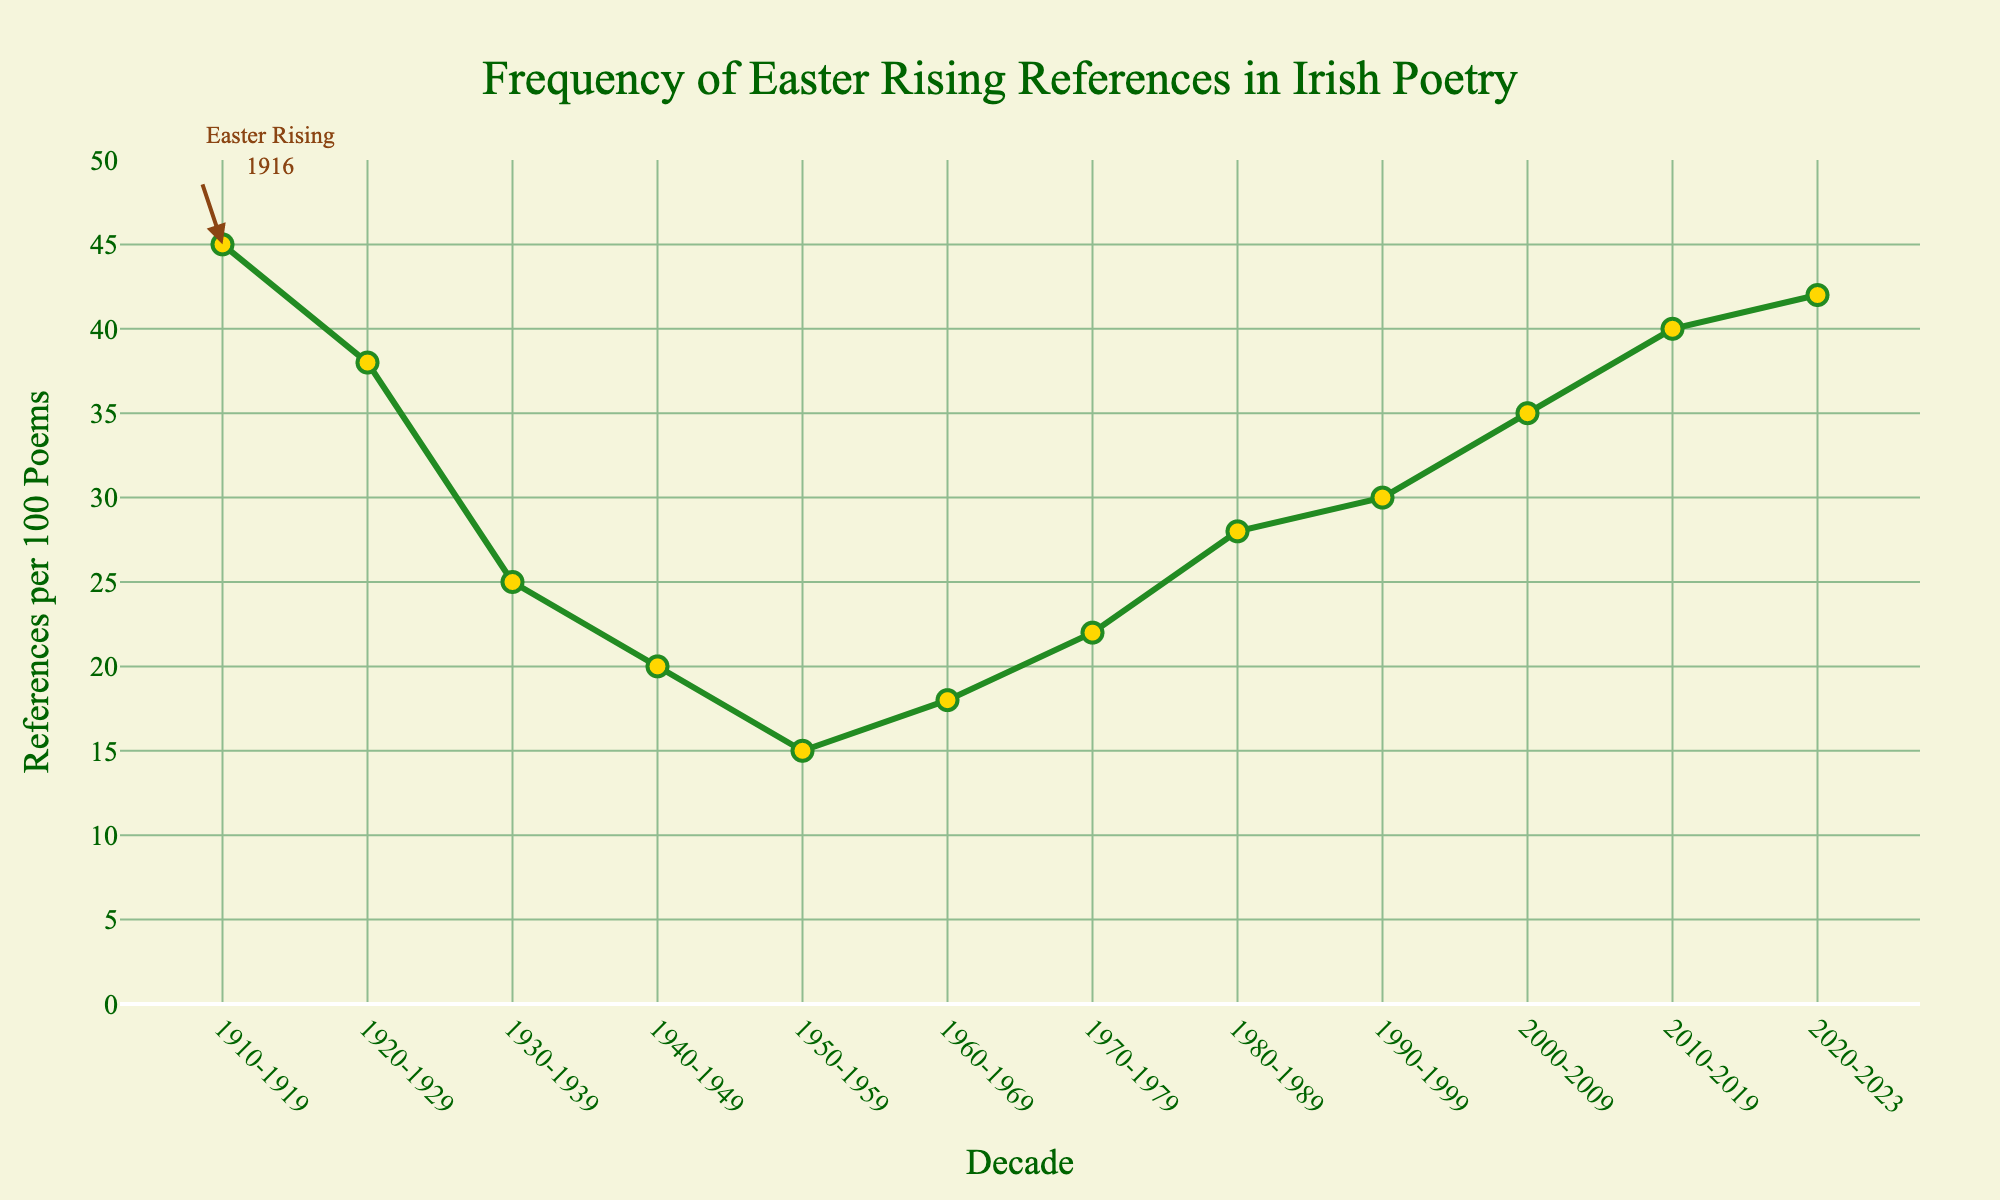Which decade shows the highest frequency of Easter Rising references? The decade with the highest point (marker) on the line plot represents the highest frequency. The marker at '1910-1919' is the highest, indicating 45 references per 100 poems.
Answer: '1910-1919' Between which two consecutive decades is the largest drop in Easter Rising references? To find the largest drop, compare the differences in references per 100 poems between each consecutive decade and identify the maximum. The difference from '1910-1919' (45) to '1920-1929' (38) is the largest drop of 7.
Answer: From '1910-1919' to '1920-1929' What is the overall trend in the frequency of references from 1910-1919 to 1950-1959? Look at the line connecting the markers from '1910-1919' to 1950-1959. The references drop continuously from 45, to 38, 25, 20, and finally 15. This shows a clear decreasing trend.
Answer: Decreasing Which decade experienced an increase in references compared to the one immediately prior to it? Compare the reference values of each decade with the one immediately before. The values increase from '1950-1959' (15) to '1960-1969' (18), '1960-1969' (18) to '1970-1979' (22), '1970-1979' (22) to '1980-1989' (28), '1980-1989' (28) to '1990-1999' (30), and '2000-2009' (35) to '2010-2019' (40), '2010-2019' (40) to '2020-2023' (42).
Answer: '1950-1959', '1960-1969', '1970-1979', '1980-1989', '1990-1999', '2000-2009', '2010-2019', '2020-2023' Based on visual inspection, how many decades show references between 30 and 40 per 100 poems? Count the markers on the y-axis that fall within the range of 30 to 40. Decades '1990-1999' (30), '2000-2009' (35), and '2010-2019' (40) fall in this range.
Answer: Three Compare the number of references in the decade 1940-1949 with 2020-2023. Which has more, and by how much? Check the y-axis for '1940-1949' (20) and '2020-2023' (42). '2020-2023' has 22 more references than '1940-1949'.
Answer: '2020-2023' has 22 more What is the average number of references per 100 poems across all decades? Sum all the reference values and divide by the number of decades (12). The sum is 358 and dividing it by 12 gives 29.83.
Answer: 29.83 In which decade do we see reference values reach their minimum, and what is that value? Look for the lowest point in the line plot. The decade '1950-1959' has the lowest marker at 15.
Answer: '1950-1959', 15 How does the frequency of references in 1970-1979 compare to that of 2010-2019? Compare the reference values at two points. '1970-1979' has 22 references per 100 poems, and '2010-2019' has 40. '2010-2019' has 18 more.
Answer: '2010-2019' has 18 more What is the rate of increase in references from 2000-2009 to 2020-2023? Calculate the increase (42 - 35 = 7) and the time interval (2 decades: 20 years). Rate of increase is 7 references over 20 years, which simplifies to 0.35 references per year.
Answer: 0.35 references per year 